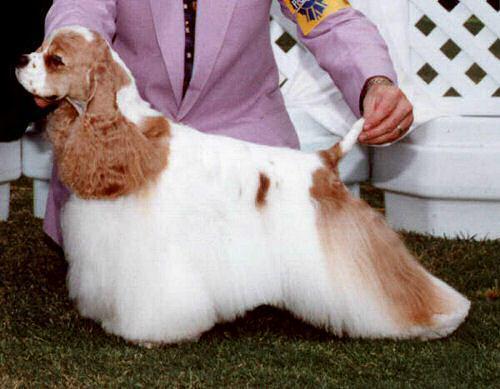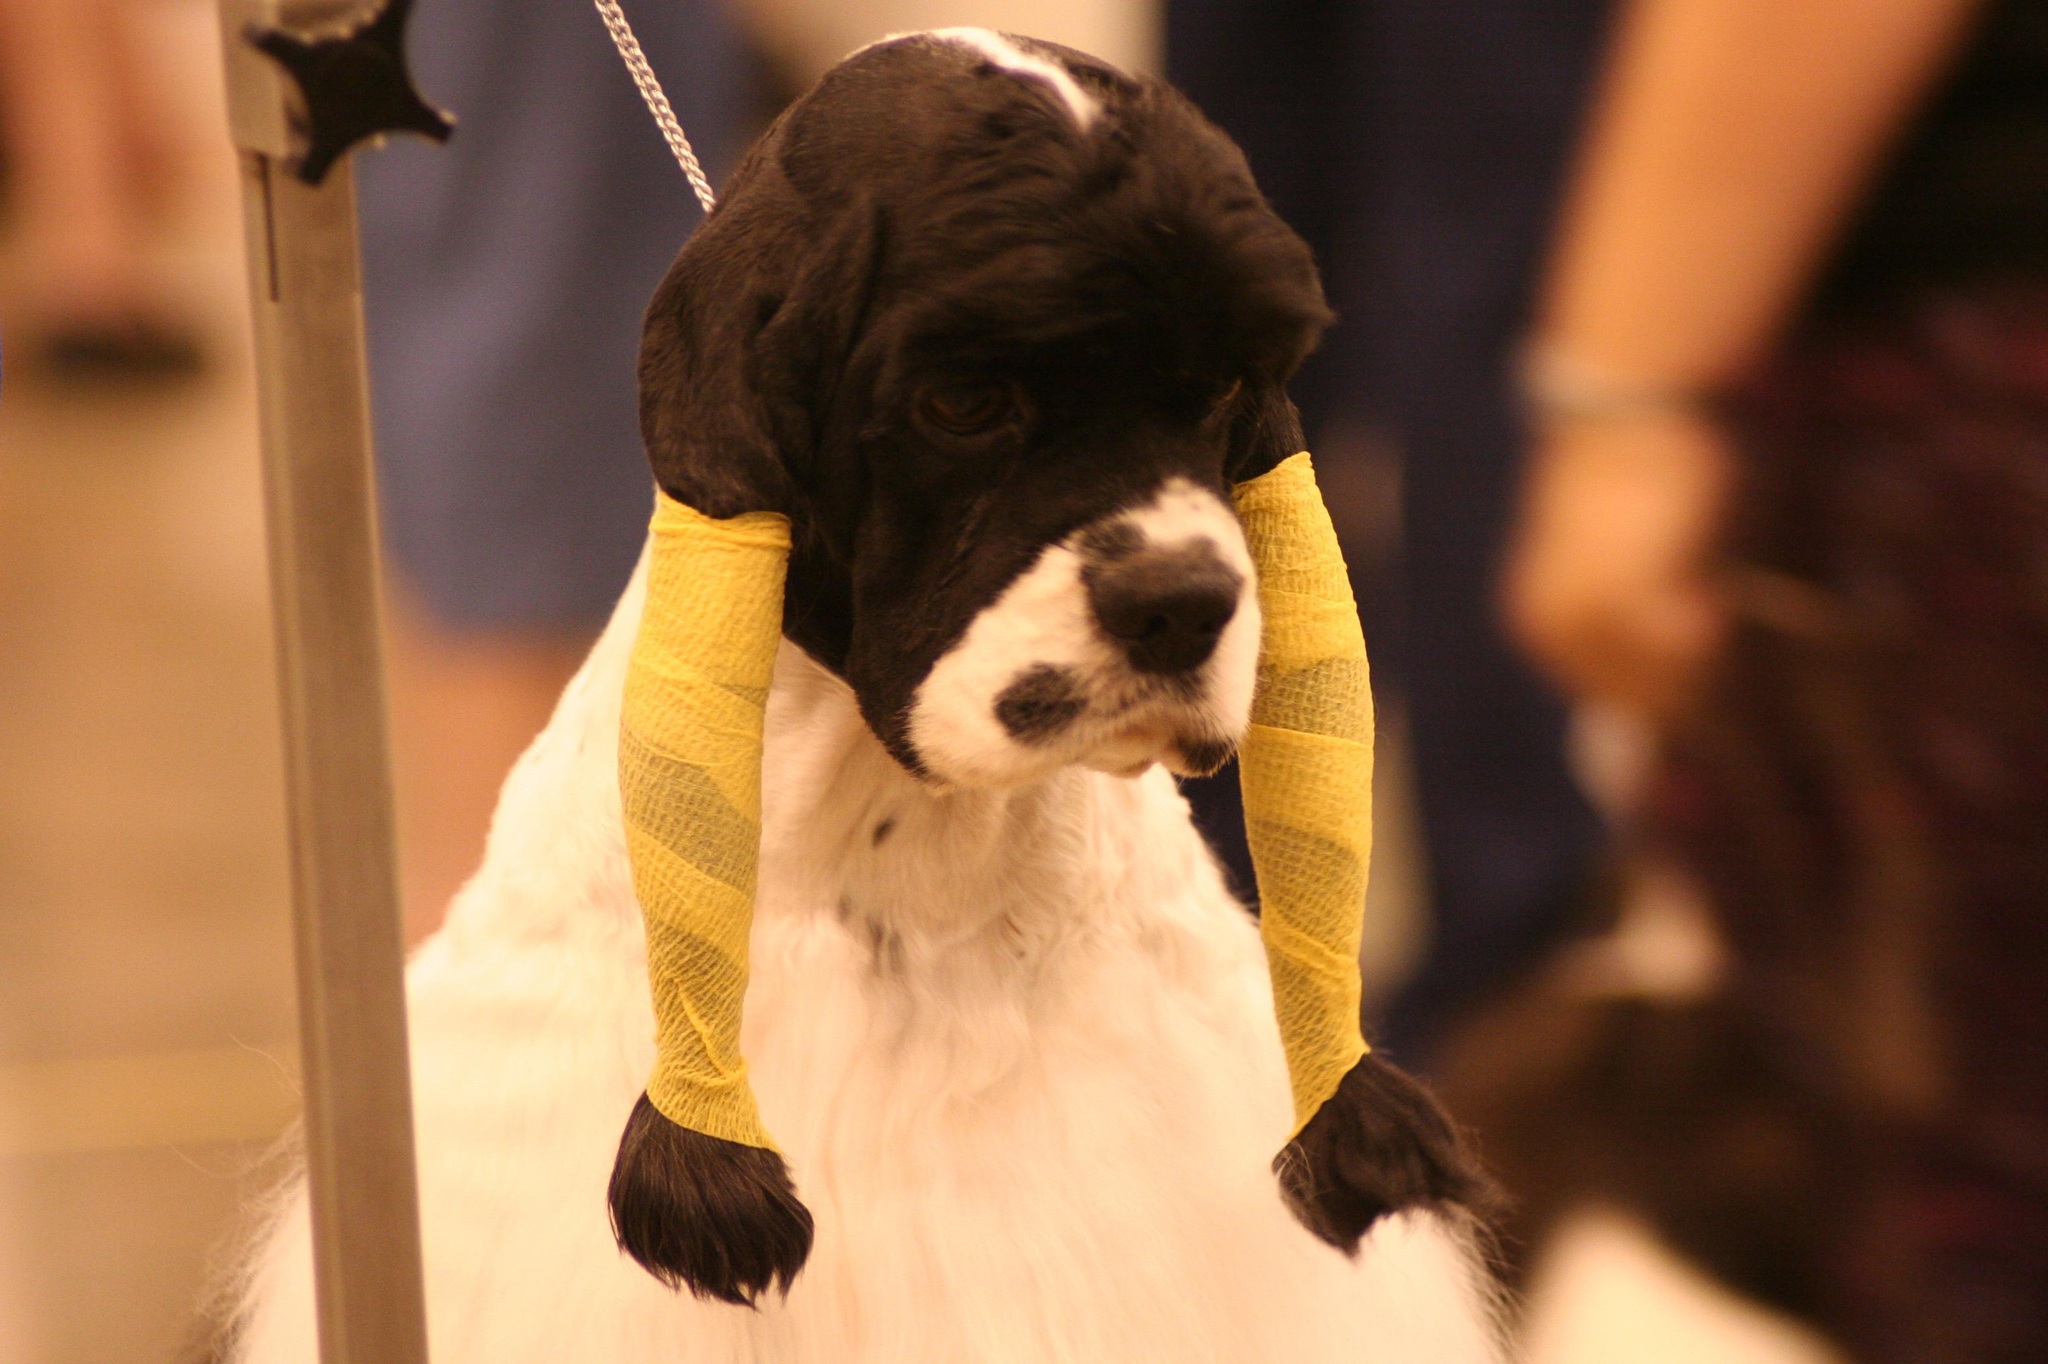The first image is the image on the left, the second image is the image on the right. Given the left and right images, does the statement "Left image shows a person standing behind a left-turned cocker spaniel, holding its chin and tail by a hand." hold true? Answer yes or no. Yes. 